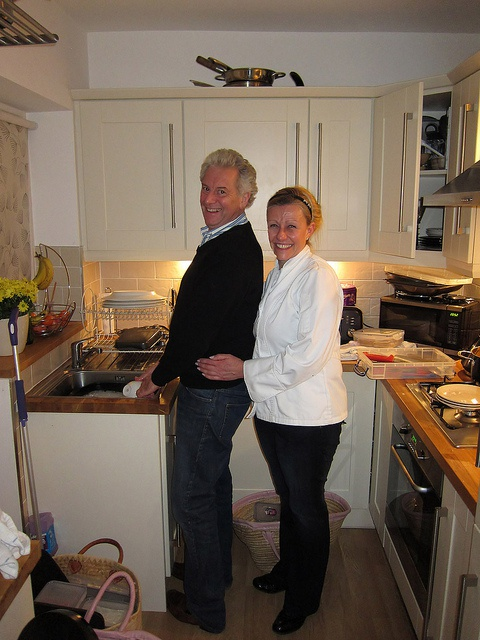Describe the objects in this image and their specific colors. I can see people in maroon, black, lightgray, darkgray, and tan tones, people in maroon, black, and brown tones, oven in maroon, black, and gray tones, microwave in maroon, black, and brown tones, and sink in maroon, black, and gray tones in this image. 